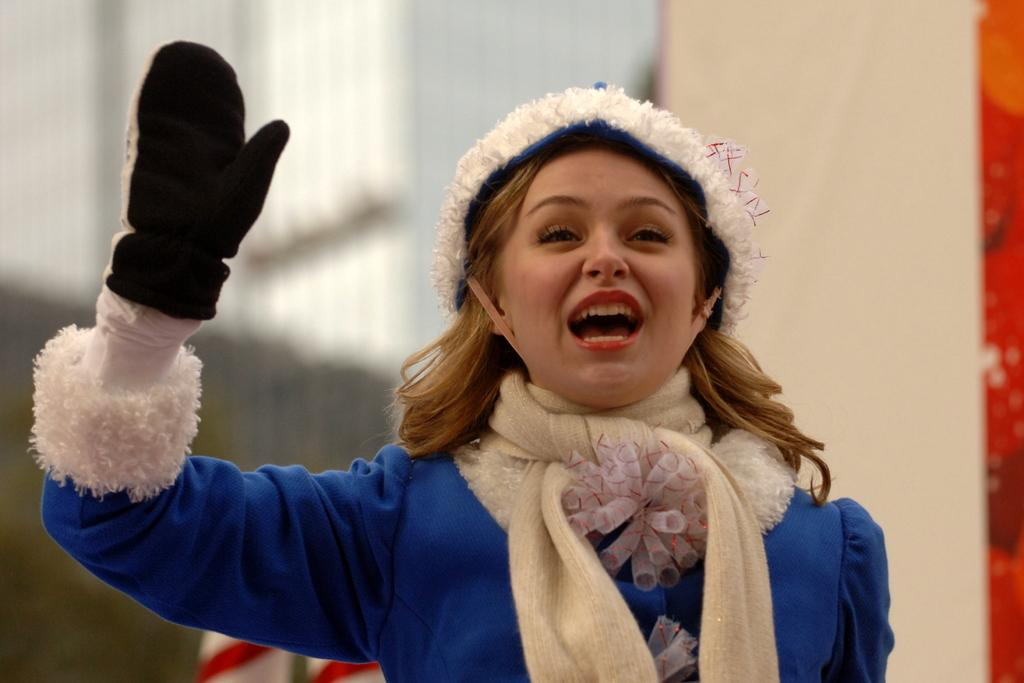Who is present in the image? There is a woman in the image. What can be observed about the woman's facial expression? The woman has an expression on her face. What is visible in the background of the image? There is a wall in the background of the image. What colors can be seen on the objects in the background? The objects in the background are white and red in color. How does the woman's thumb contribute to the pollution in the image? There is no mention of pollution or the woman's thumb in the image, so it cannot be determined how they might be related. 